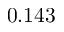<formula> <loc_0><loc_0><loc_500><loc_500>0 . 1 4 3</formula> 